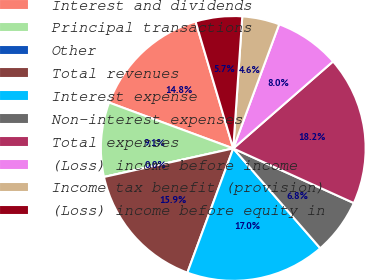Convert chart to OTSL. <chart><loc_0><loc_0><loc_500><loc_500><pie_chart><fcel>Interest and dividends<fcel>Principal transactions<fcel>Other<fcel>Total revenues<fcel>Interest expense<fcel>Non-interest expenses<fcel>Total expenses<fcel>(Loss) income before income<fcel>Income tax benefit (provision)<fcel>(Loss) income before equity in<nl><fcel>14.77%<fcel>9.09%<fcel>0.0%<fcel>15.91%<fcel>17.04%<fcel>6.82%<fcel>18.18%<fcel>7.95%<fcel>4.55%<fcel>5.68%<nl></chart> 